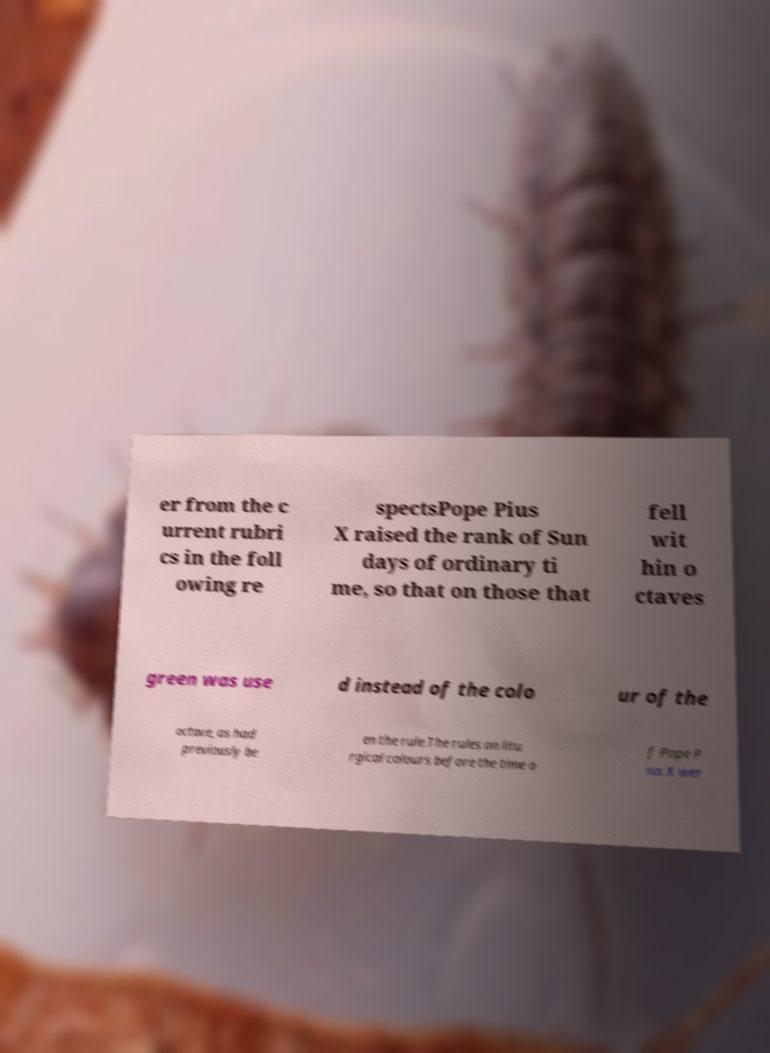I need the written content from this picture converted into text. Can you do that? er from the c urrent rubri cs in the foll owing re spectsPope Pius X raised the rank of Sun days of ordinary ti me, so that on those that fell wit hin o ctaves green was use d instead of the colo ur of the octave, as had previously be en the rule.The rules on litu rgical colours before the time o f Pope P ius X wer 